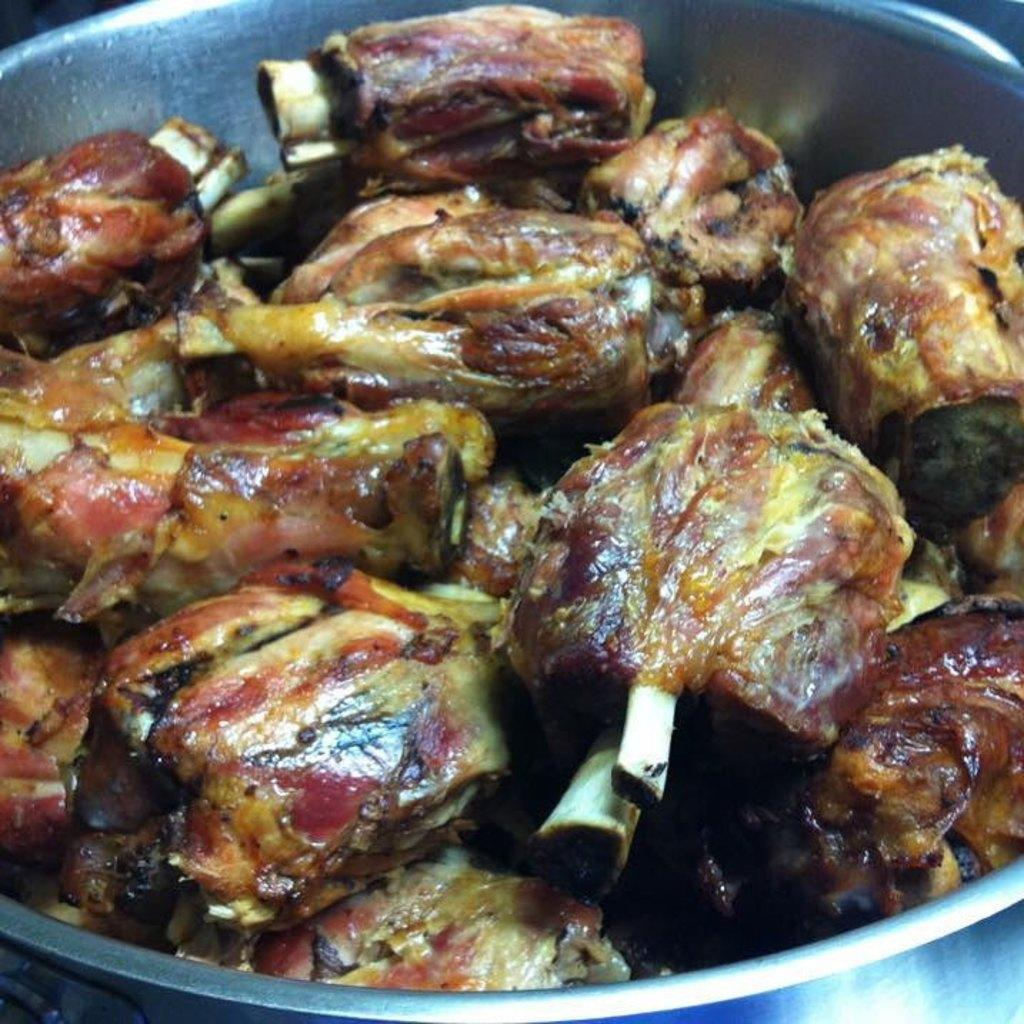What is the main subject of the image? There is a food item in the image. How is the food item presented in the image? The food item is in a bowl. What scientific discovery is depicted in the image? There is no scientific discovery depicted in the image; it features a food item in a bowl. What is the plot of the story unfolding in the image? There is no story or plot depicted in the image; it simply shows a food item in a bowl. 